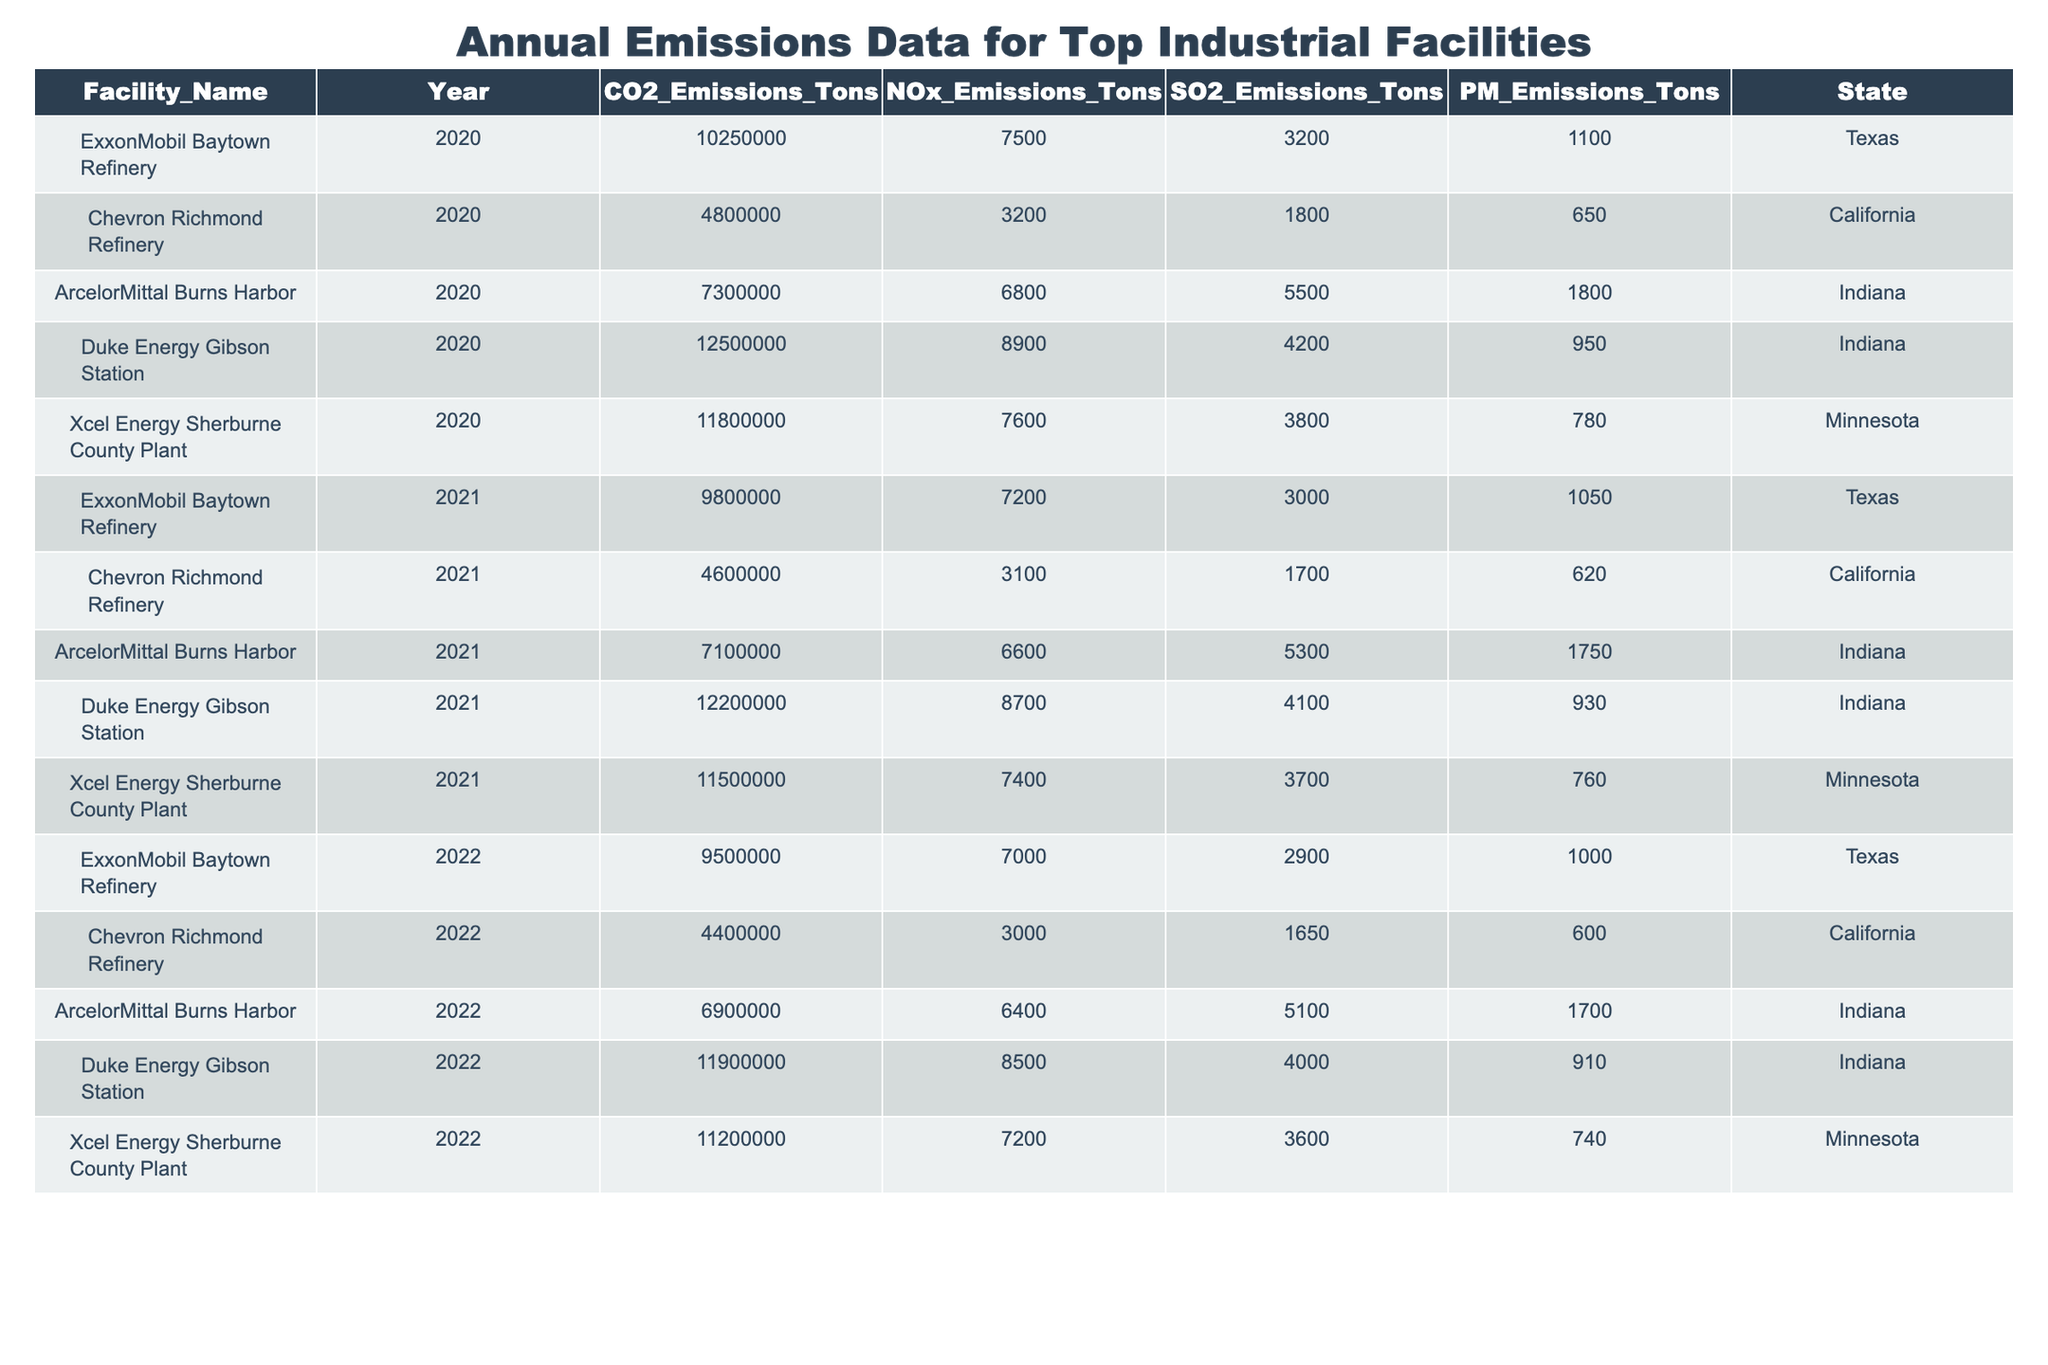What is the facility with the highest CO2 emissions in 2020? The table lists CO2 emissions for each facility by year. Looking at the 2020 emissions, Duke Energy Gibson Station has the highest CO2 emissions at 12,500,000 tons.
Answer: Duke Energy Gibson Station How much NOx did Chevron Richmond Refinery emit in 2021? In the year 2021, Chevron Richmond Refinery’s NOx emissions are listed as 3,100 tons.
Answer: 3100 tons What is the total SO2 emissions from ArcelorMittal Burns Harbor for the years 2020, 2021, and 2022? To find the total SO2 emissions for ArcelorMittal Burns Harbor, sum the emissions for the three years: 5,500 (2020) + 5,300 (2021) + 5,100 (2022) = 15,900 tons.
Answer: 15900 tons Did Xcel Energy Sherburne County Plant have an increase or decrease in PM emissions from 2020 to 2021? In 2020, the PM emissions for Xcel Energy Sherburne County Plant were 780 tons, and in 2021 they were 760 tons, indicating a decrease in PM emissions.
Answer: Decrease Which state had the highest total CO2 emissions across all facilities in 2020? Calculate the total CO2 emissions for each state in 2020: Texas (10,250,000), California (4,800,000), Indiana (7,300,000 + 12,500,000 = 19,800,000), Minnesota (11,800,000). Indiana has the highest total CO2 emissions at 19,800,000 tons.
Answer: Indiana What was the average NOx emissions for Duke Energy Gibson Station over the three years? Duke Energy Gibson Station had NOx emissions of 8,900 (2020), 8,700 (2021), and 8,500 (2022). The average is calculated as (8,900 + 8,700 + 8,500) / 3 = 8,700 tons.
Answer: 8700 tons Is it true that Chevron Richmond Refinery had more SO2 emissions in 2021 than in 2020? The SO2 emissions for Chevron Richmond Refinery were 1,800 tons in 2020 and 1,700 tons in 2021. Since 1,700 is less than 1,800, the statement is false.
Answer: False Which facility had the lowest PM emissions in 2022? Looking at PM emissions for all facilities in 2022, Chevron Richmond Refinery emitted 600 tons, which is the lowest compared to the other facilities' emissions that year.
Answer: Chevron Richmond Refinery What was the percentage decrease in CO2 emissions for ExxonMobil Baytown Refinery from 2020 to 2022? CO2 emissions in 2020 were 10,250,000 tons and in 2022 were 9,500,000 tons. The decrease is calculated as (10,250,000 - 9,500,000) / 10,250,000 * 100 = 7.32%.
Answer: 7.32% What was the maximum SO2 emissions recorded across all facilities in 2021? Reviewing the SO2 emissions for each facility in 2021, Duke Energy Gibson Station had the highest SO2 emissions at 4,100 tons.
Answer: 4100 tons 